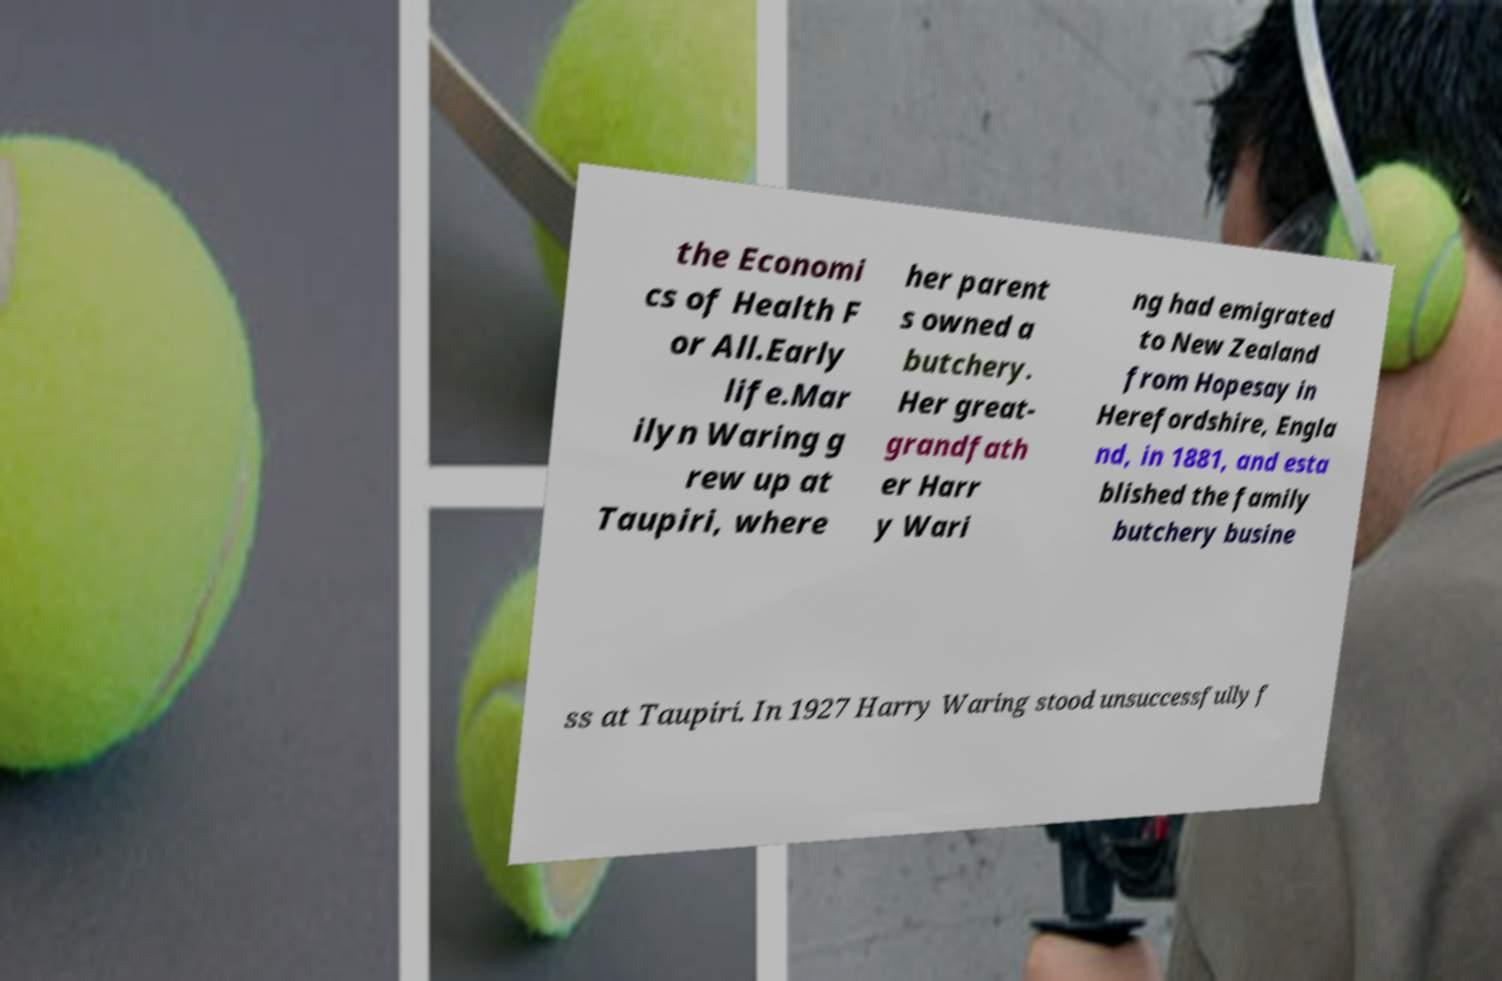Can you read and provide the text displayed in the image?This photo seems to have some interesting text. Can you extract and type it out for me? the Economi cs of Health F or All.Early life.Mar ilyn Waring g rew up at Taupiri, where her parent s owned a butchery. Her great- grandfath er Harr y Wari ng had emigrated to New Zealand from Hopesay in Herefordshire, Engla nd, in 1881, and esta blished the family butchery busine ss at Taupiri. In 1927 Harry Waring stood unsuccessfully f 